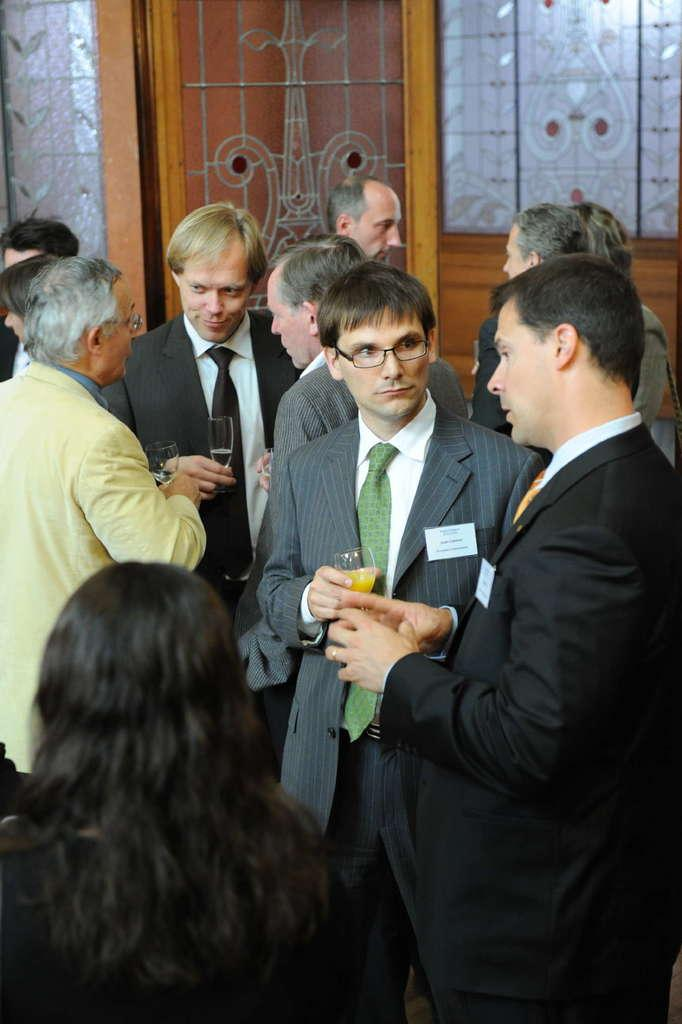How many people are in the image? There are people in the image, but the exact number is not specified. What are the people doing in the image? The people are talking to each other in the image. What are the people holding in their hands? The people are holding wine glasses in the image. What can be seen in the background of the image? There is a glass window in the background of the image. What type of dust can be seen on the legs of the table in the image? There is no table or dust present in the image. What season is it in the image? The season is not mentioned in the image or the provided facts. 